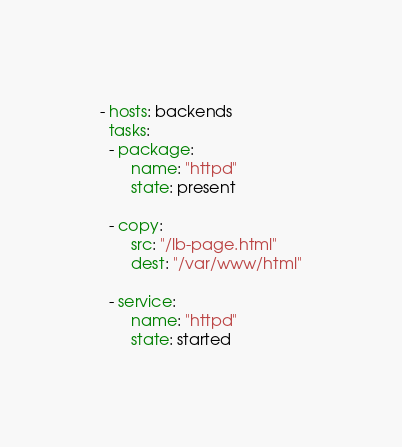<code> <loc_0><loc_0><loc_500><loc_500><_YAML_>- hosts: backends
  tasks:
  - package:
       name: "httpd"
       state: present

  - copy:
       src: "/lb-page.html"
       dest: "/var/www/html"
 
  - service:  
       name: "httpd"
       state: started
</code> 